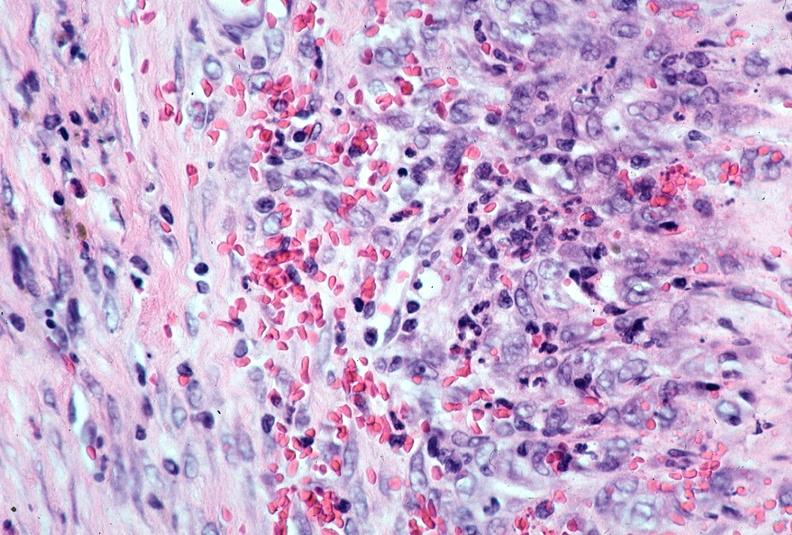does this image show vasculitis, polyarteritis nodosa?
Answer the question using a single word or phrase. Yes 